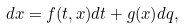<formula> <loc_0><loc_0><loc_500><loc_500>d x & = f ( t , x ) d t + g ( x ) d q ,</formula> 